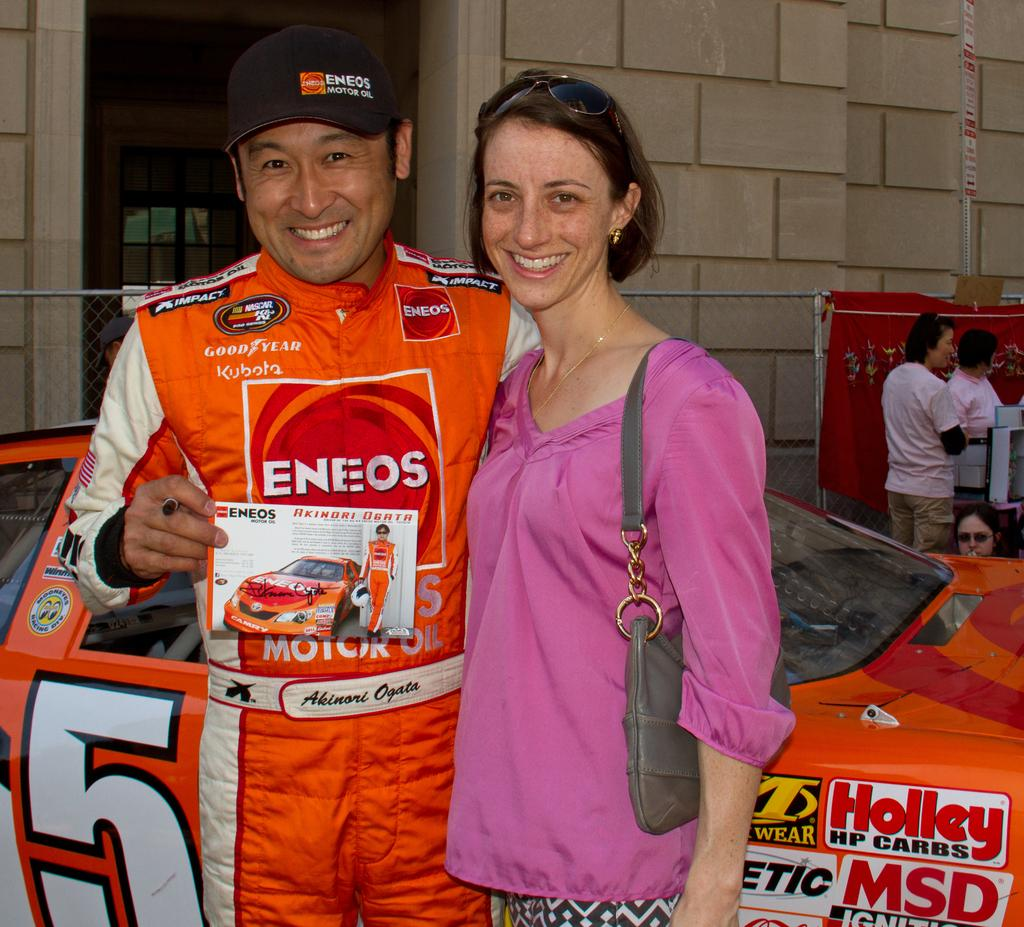<image>
Present a compact description of the photo's key features. The sportman pictured has the tyre make Goodyear on his clothing. 